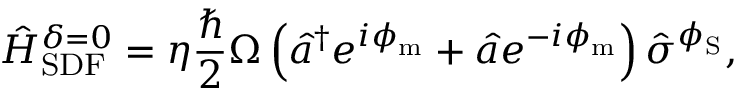<formula> <loc_0><loc_0><loc_500><loc_500>\hat { H } _ { S D F } ^ { \delta = 0 } = \eta \frac { } { 2 } \Omega \left ( \hat { a } ^ { \dagger } e ^ { i \phi _ { m } } + \hat { a } e ^ { - i \phi _ { m } } \right ) \hat { \sigma } ^ { \phi _ { S } } ,</formula> 